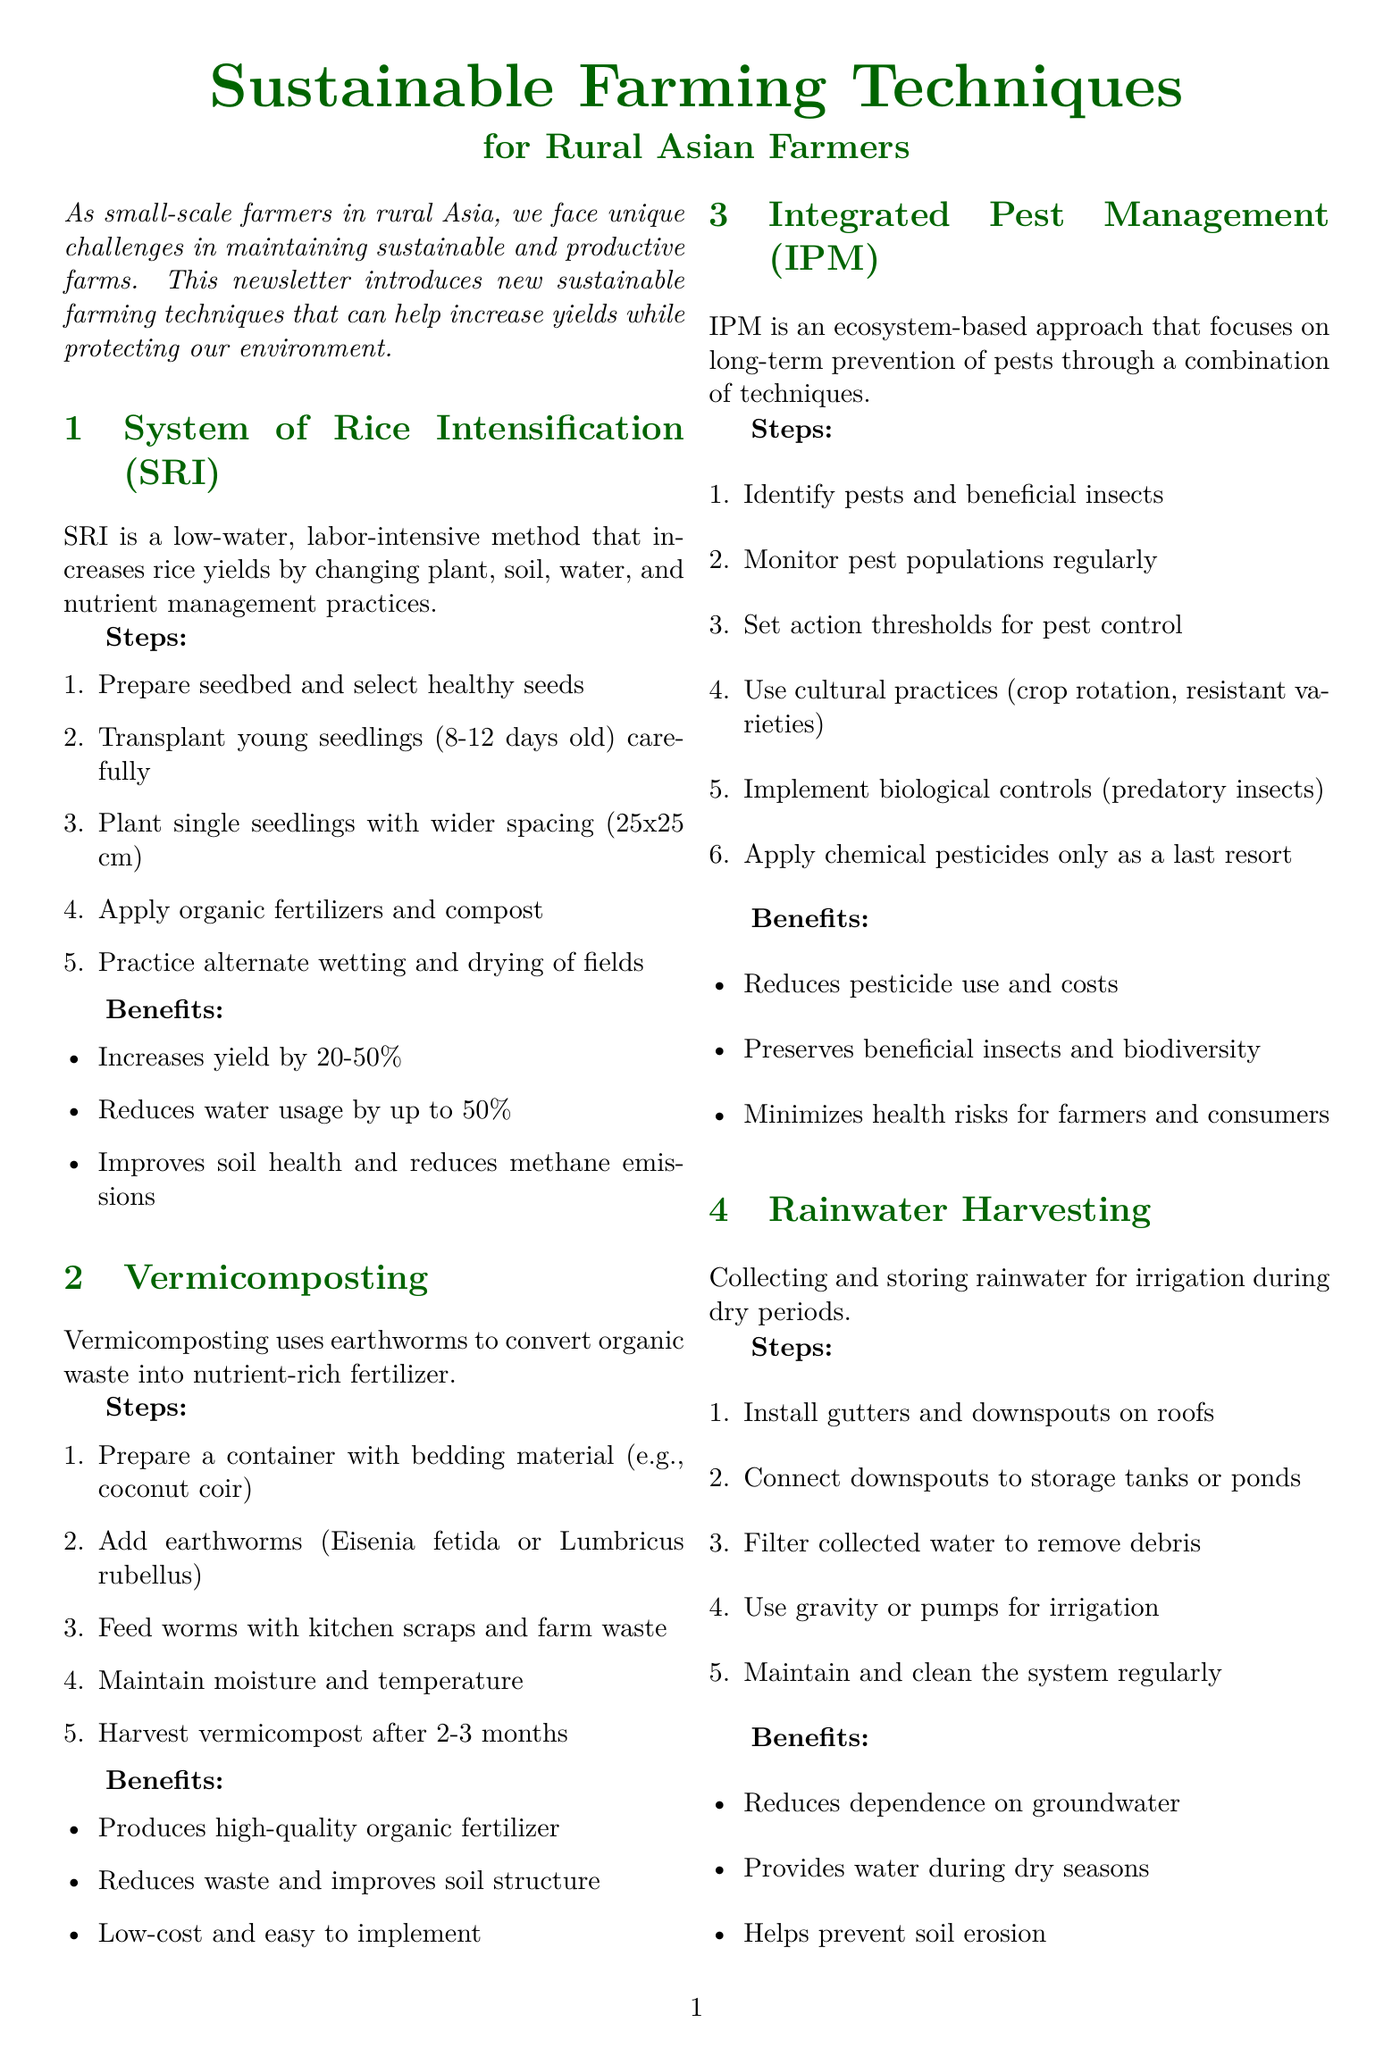What is the title of the newsletter? The title of the newsletter is stated prominently at the beginning of the document.
Answer: Sustainable Farming Techniques for Rural Asian Farmers What technique increases rice yields? The technique that specifically focuses on increasing rice yields is mentioned in the document under its own section.
Answer: System of Rice Intensification How many steps are there for vermicomposting? The steps for vermicomposting are listed in the document, and counting them provides the answer.
Answer: Five What is one benefit of Integrated Pest Management? The benefits of Integrated Pest Management are outlined, and one example can be chosen from that list.
Answer: Reduces pesticide use and costs Which organization is located in Thailand? The document lists training centers with their locations, identifying which is in Thailand provides the answer.
Answer: Asian Institute of Technology What is the method used in rainwater harvesting? The specific activity that is the core of rainwater harvesting is described in the steps section of that technique.
Answer: Collecting and storing rainwater How much can rice yield increase with SRI? The benefits section for System of Rice Intensification lists the potential yield increase, which can be directly referenced.
Answer: 20-50% What is an example of a farmer cooperative? The document provides examples of farmer cooperatives and one can be chosen from that list.
Answer: Mekong Organic Farmers Association 